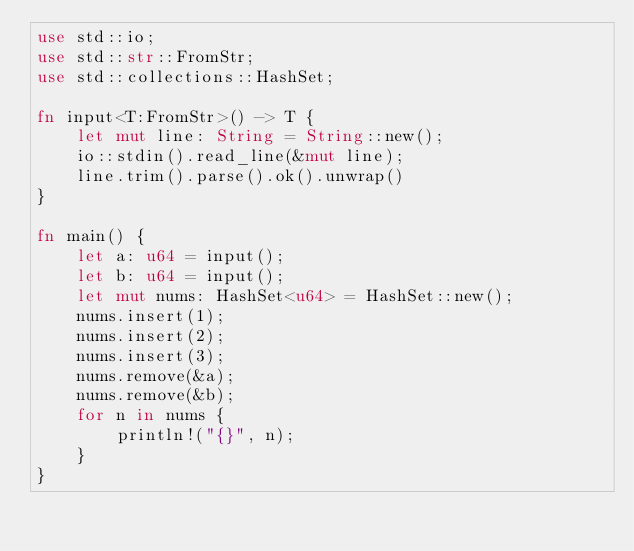<code> <loc_0><loc_0><loc_500><loc_500><_Rust_>use std::io;
use std::str::FromStr;
use std::collections::HashSet;

fn input<T:FromStr>() -> T {
    let mut line: String = String::new();
    io::stdin().read_line(&mut line);
    line.trim().parse().ok().unwrap()
}

fn main() {
    let a: u64 = input();
    let b: u64 = input();
    let mut nums: HashSet<u64> = HashSet::new();
    nums.insert(1);
    nums.insert(2);
    nums.insert(3);
    nums.remove(&a);
    nums.remove(&b);
    for n in nums {
        println!("{}", n);
    }
}
</code> 